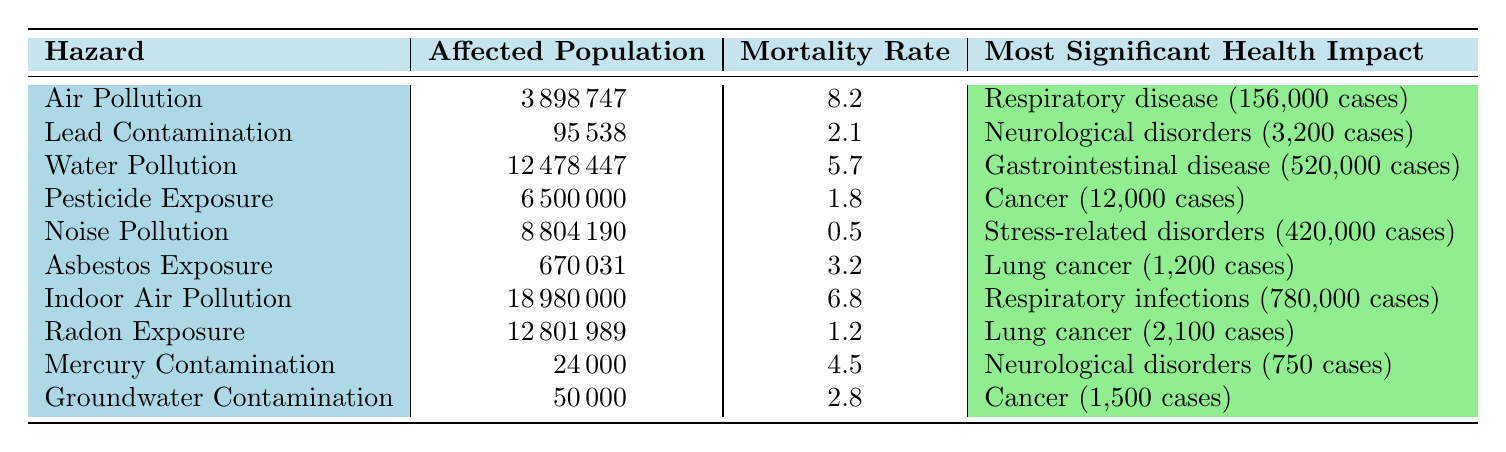What is the affected population for Air Pollution in Los Angeles? The table directly provides the affected population for Air Pollution in Los Angeles, which can be found in the corresponding row. The value listed is 3,898,747.
Answer: 3,898,747 Which hazard has the highest mortality rate? By comparing the mortality rates listed in the table, the highest value is 8.2, associated with Air Pollution.
Answer: Air Pollution How many total respiratory disease cases are there from Indoor Air Pollution and Air Pollution combined? The total respiratory disease cases can be calculated by summing the cases from both hazards. Indoor Air Pollution has 780,000 cases and Air Pollution has 156,000 cases. The sum is 780,000 + 156,000 = 936,000.
Answer: 936,000 Is the mortality rate for Noise Pollution greater than that for Lead Contamination? The table shows that the mortality rate for Noise Pollution is 0.5 and for Lead Contamination is 2.1. Since 0.5 is less than 2.1, the statement is false.
Answer: No What is the total number of cancer cases reported for Pesticide Exposure and Groundwater Contamination? To find the total number of cancer cases, we need to add the cases from Pesticide Exposure (12,000) and Groundwater Contamination (1,500). The calculation is 12,000 + 1,500 = 13,500.
Answer: 13,500 Which location has the highest affected population among the hazards listed? By examining the affected population column, Indoor Air Pollution has the highest affected population at 18,980,000, compared to other hazards.
Answer: Delhi Are there more cases of neurological disorders related to Lead Contamination than to Mercury Contamination? The neurological disorders cases are 3,200 for Lead Contamination and 750 for Mercury Contamination. Since 3,200 is greater than 750, the answer is yes.
Answer: Yes What is the average mortality rate of the hazards listed in the table? To find the average mortality rate, we sum the mortality rates (8.2 + 2.1 + 5.7 + 1.8 + 0.5 + 3.2 + 6.8 + 1.2 + 4.5 + 2.8 = 36.8) and then divide by the total number of hazards (10). The average is 36.8 / 10 = 3.68.
Answer: 3.68 What is the most significant health impact of Water Pollution? The table specifies that the most significant health impact of Water Pollution is gastrointestinal disease with 520,000 cases.
Answer: Gastrointestinal disease (520,000 cases) 